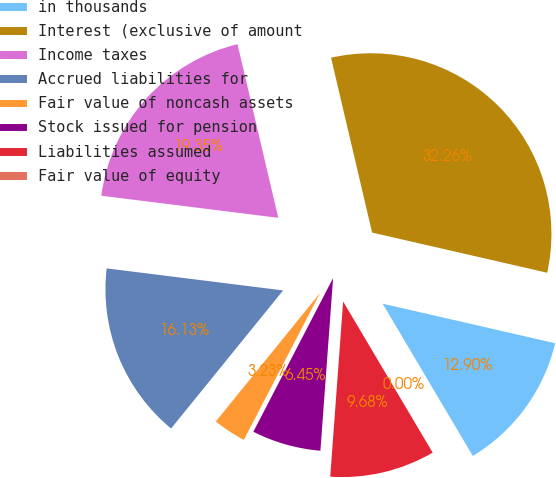<chart> <loc_0><loc_0><loc_500><loc_500><pie_chart><fcel>in thousands<fcel>Interest (exclusive of amount<fcel>Income taxes<fcel>Accrued liabilities for<fcel>Fair value of noncash assets<fcel>Stock issued for pension<fcel>Liabilities assumed<fcel>Fair value of equity<nl><fcel>12.9%<fcel>32.26%<fcel>19.35%<fcel>16.13%<fcel>3.23%<fcel>6.45%<fcel>9.68%<fcel>0.0%<nl></chart> 